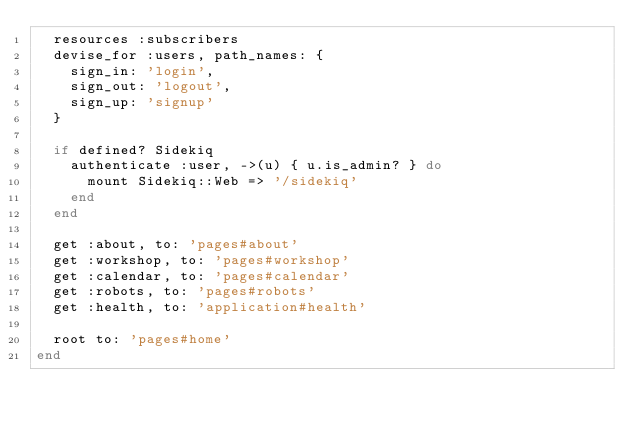Convert code to text. <code><loc_0><loc_0><loc_500><loc_500><_Ruby_>  resources :subscribers
  devise_for :users, path_names: {
    sign_in: 'login',
    sign_out: 'logout',
    sign_up: 'signup'
  }

  if defined? Sidekiq
    authenticate :user, ->(u) { u.is_admin? } do
      mount Sidekiq::Web => '/sidekiq'
    end
  end

  get :about, to: 'pages#about'
  get :workshop, to: 'pages#workshop'
  get :calendar, to: 'pages#calendar'
  get :robots, to: 'pages#robots'
  get :health, to: 'application#health'

  root to: 'pages#home'
end
</code> 